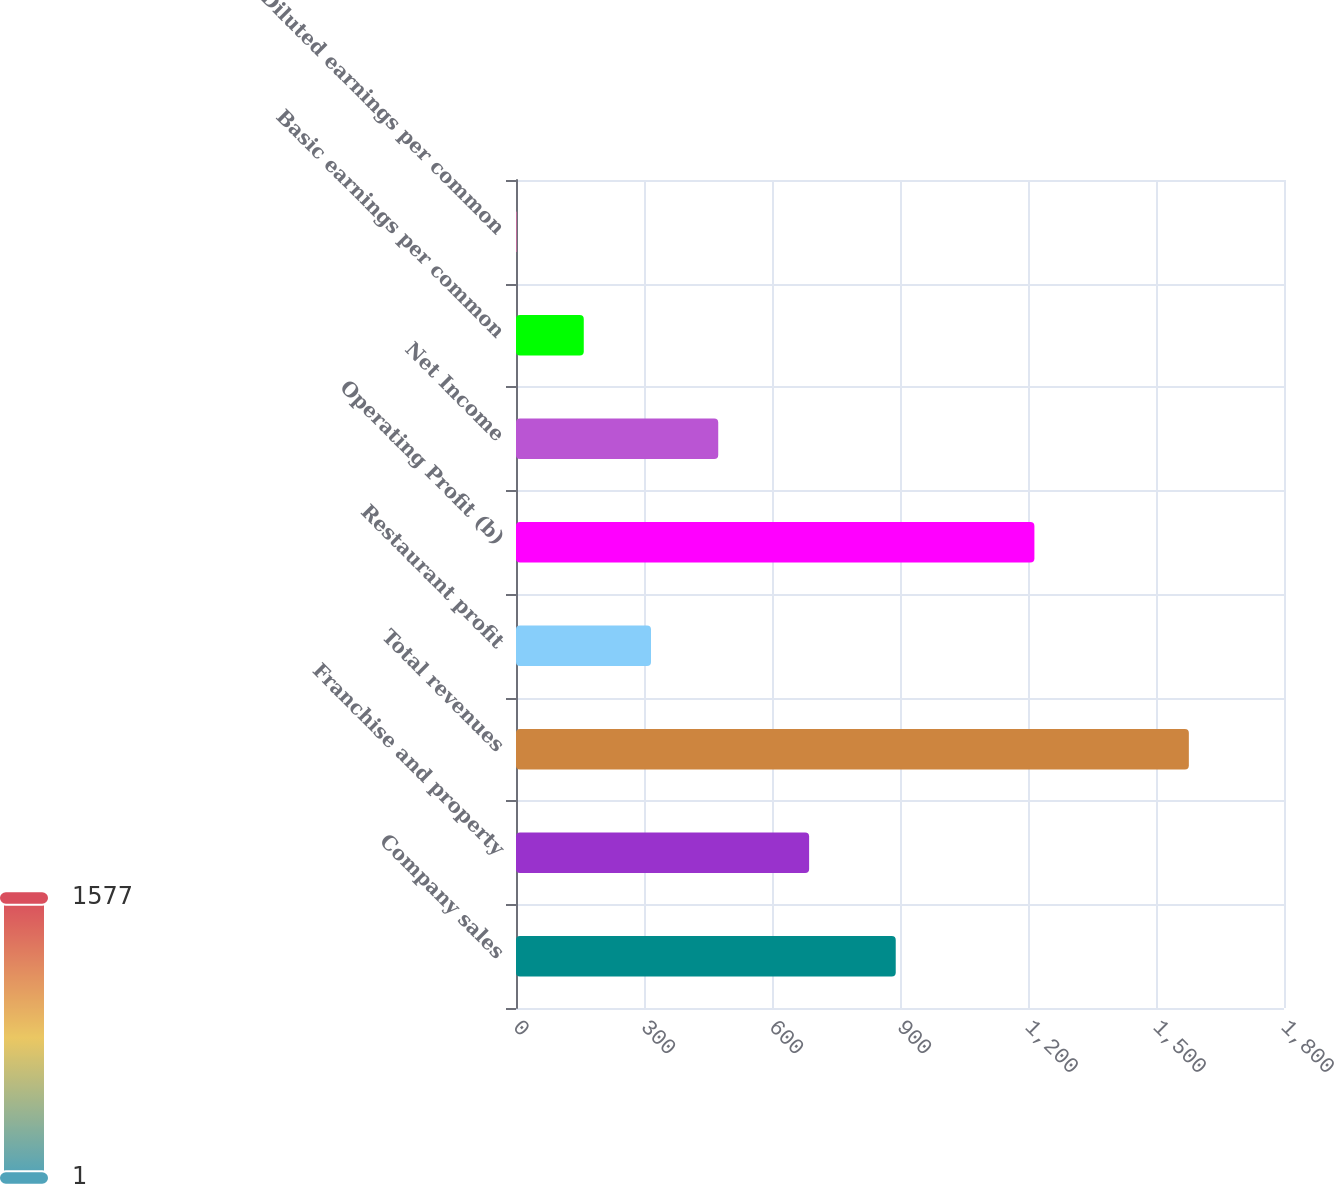Convert chart to OTSL. <chart><loc_0><loc_0><loc_500><loc_500><bar_chart><fcel>Company sales<fcel>Franchise and property<fcel>Total revenues<fcel>Restaurant profit<fcel>Operating Profit (b)<fcel>Net Income<fcel>Basic earnings per common<fcel>Diluted earnings per common<nl><fcel>890<fcel>687<fcel>1577<fcel>316.4<fcel>1215<fcel>473.97<fcel>158.83<fcel>1.26<nl></chart> 